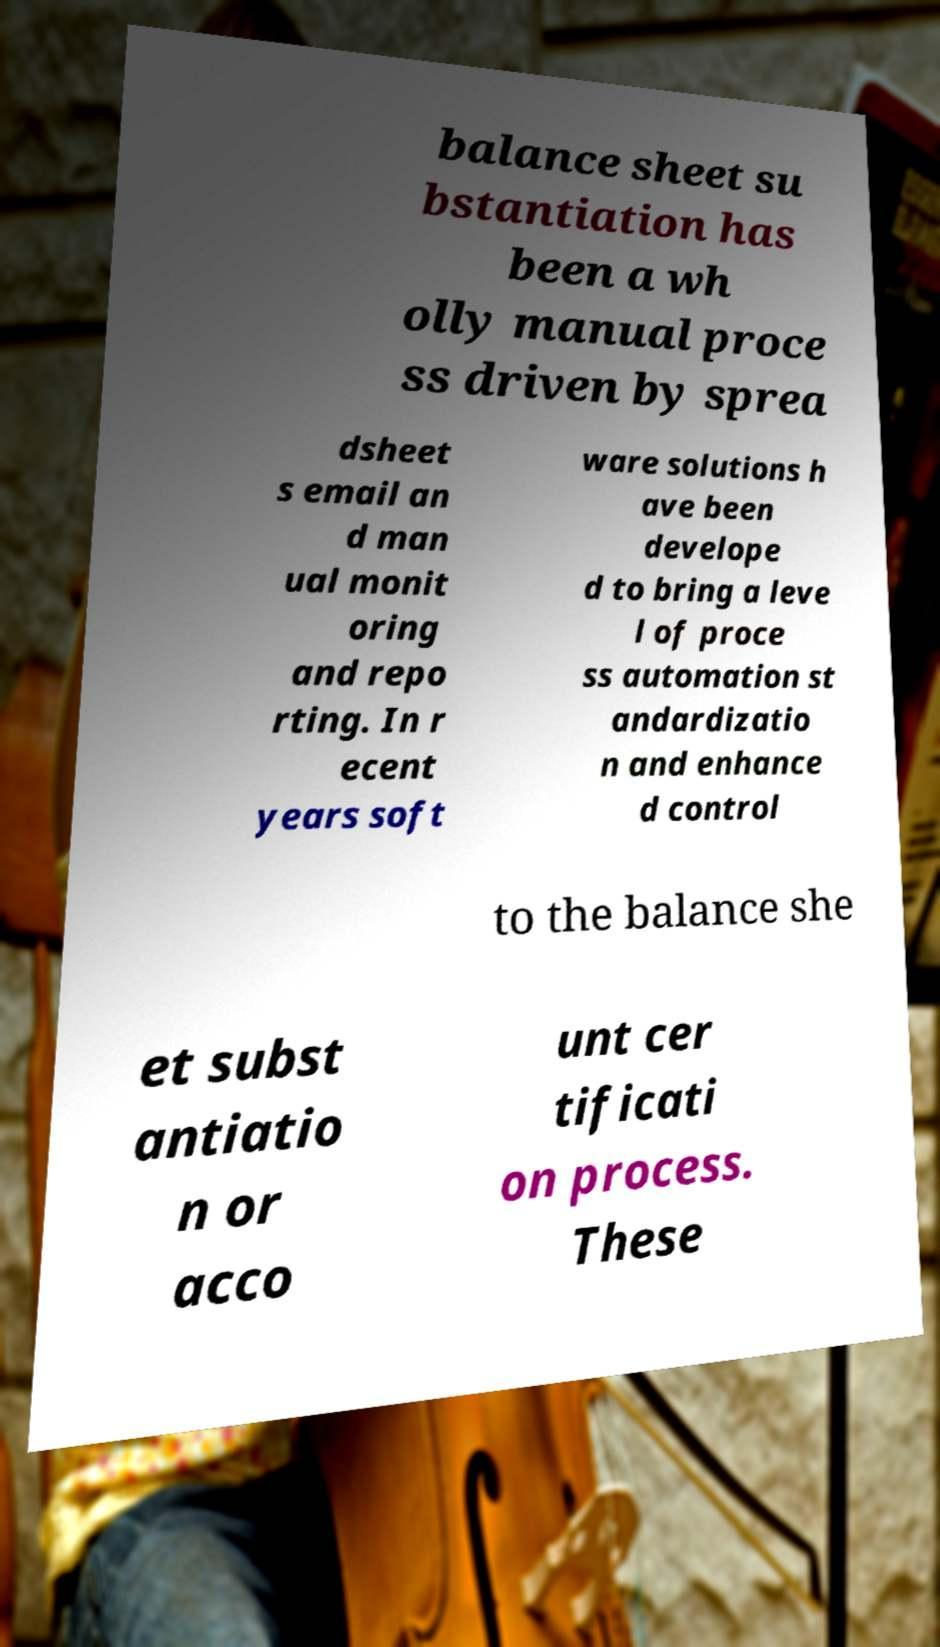Please identify and transcribe the text found in this image. balance sheet su bstantiation has been a wh olly manual proce ss driven by sprea dsheet s email an d man ual monit oring and repo rting. In r ecent years soft ware solutions h ave been develope d to bring a leve l of proce ss automation st andardizatio n and enhance d control to the balance she et subst antiatio n or acco unt cer tificati on process. These 